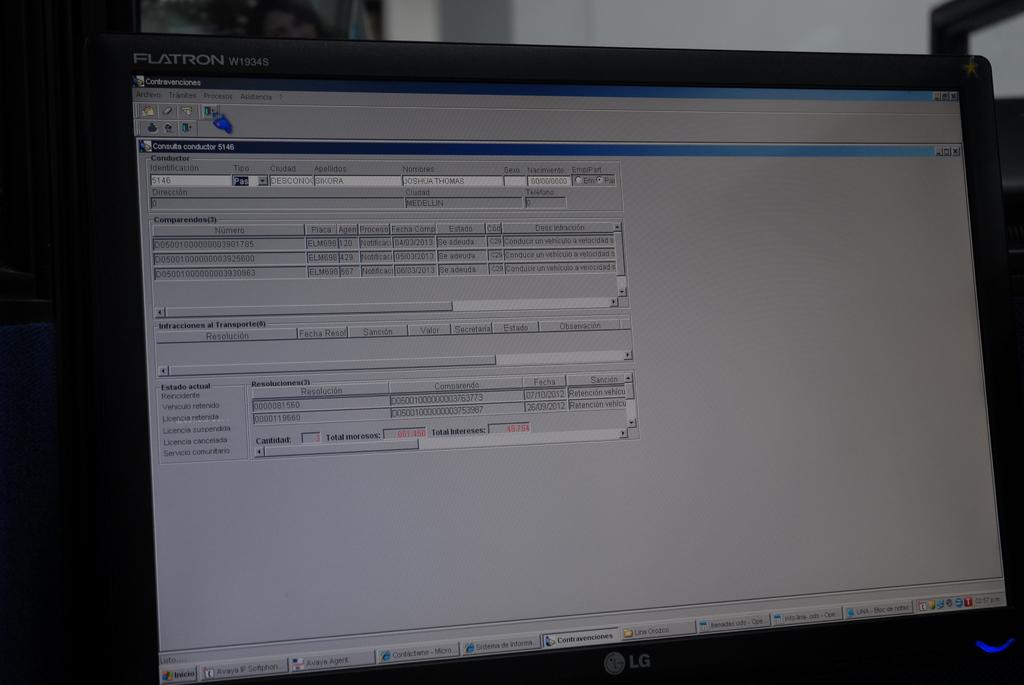What is the monitor type?
Make the answer very short. Lg. What is the brand of monitor?
Your answer should be very brief. Flatron. 